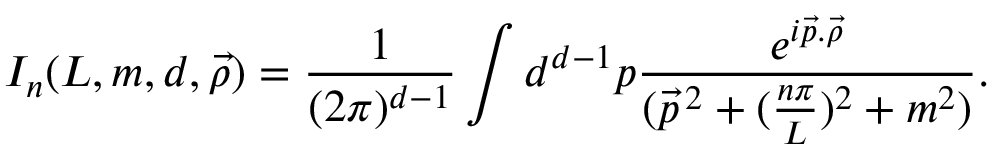Convert formula to latex. <formula><loc_0><loc_0><loc_500><loc_500>I _ { n } ( L , m , d , \vec { \rho } ) = \frac { 1 } { ( 2 \pi ) ^ { d - 1 } } d ^ { d - 1 } p \frac { e ^ { i \vec { p } . \vec { \rho } } } { ( \vec { p } ^ { \, 2 } + ( \frac { n \pi } { L } ) ^ { 2 } + m ^ { 2 } ) } .</formula> 